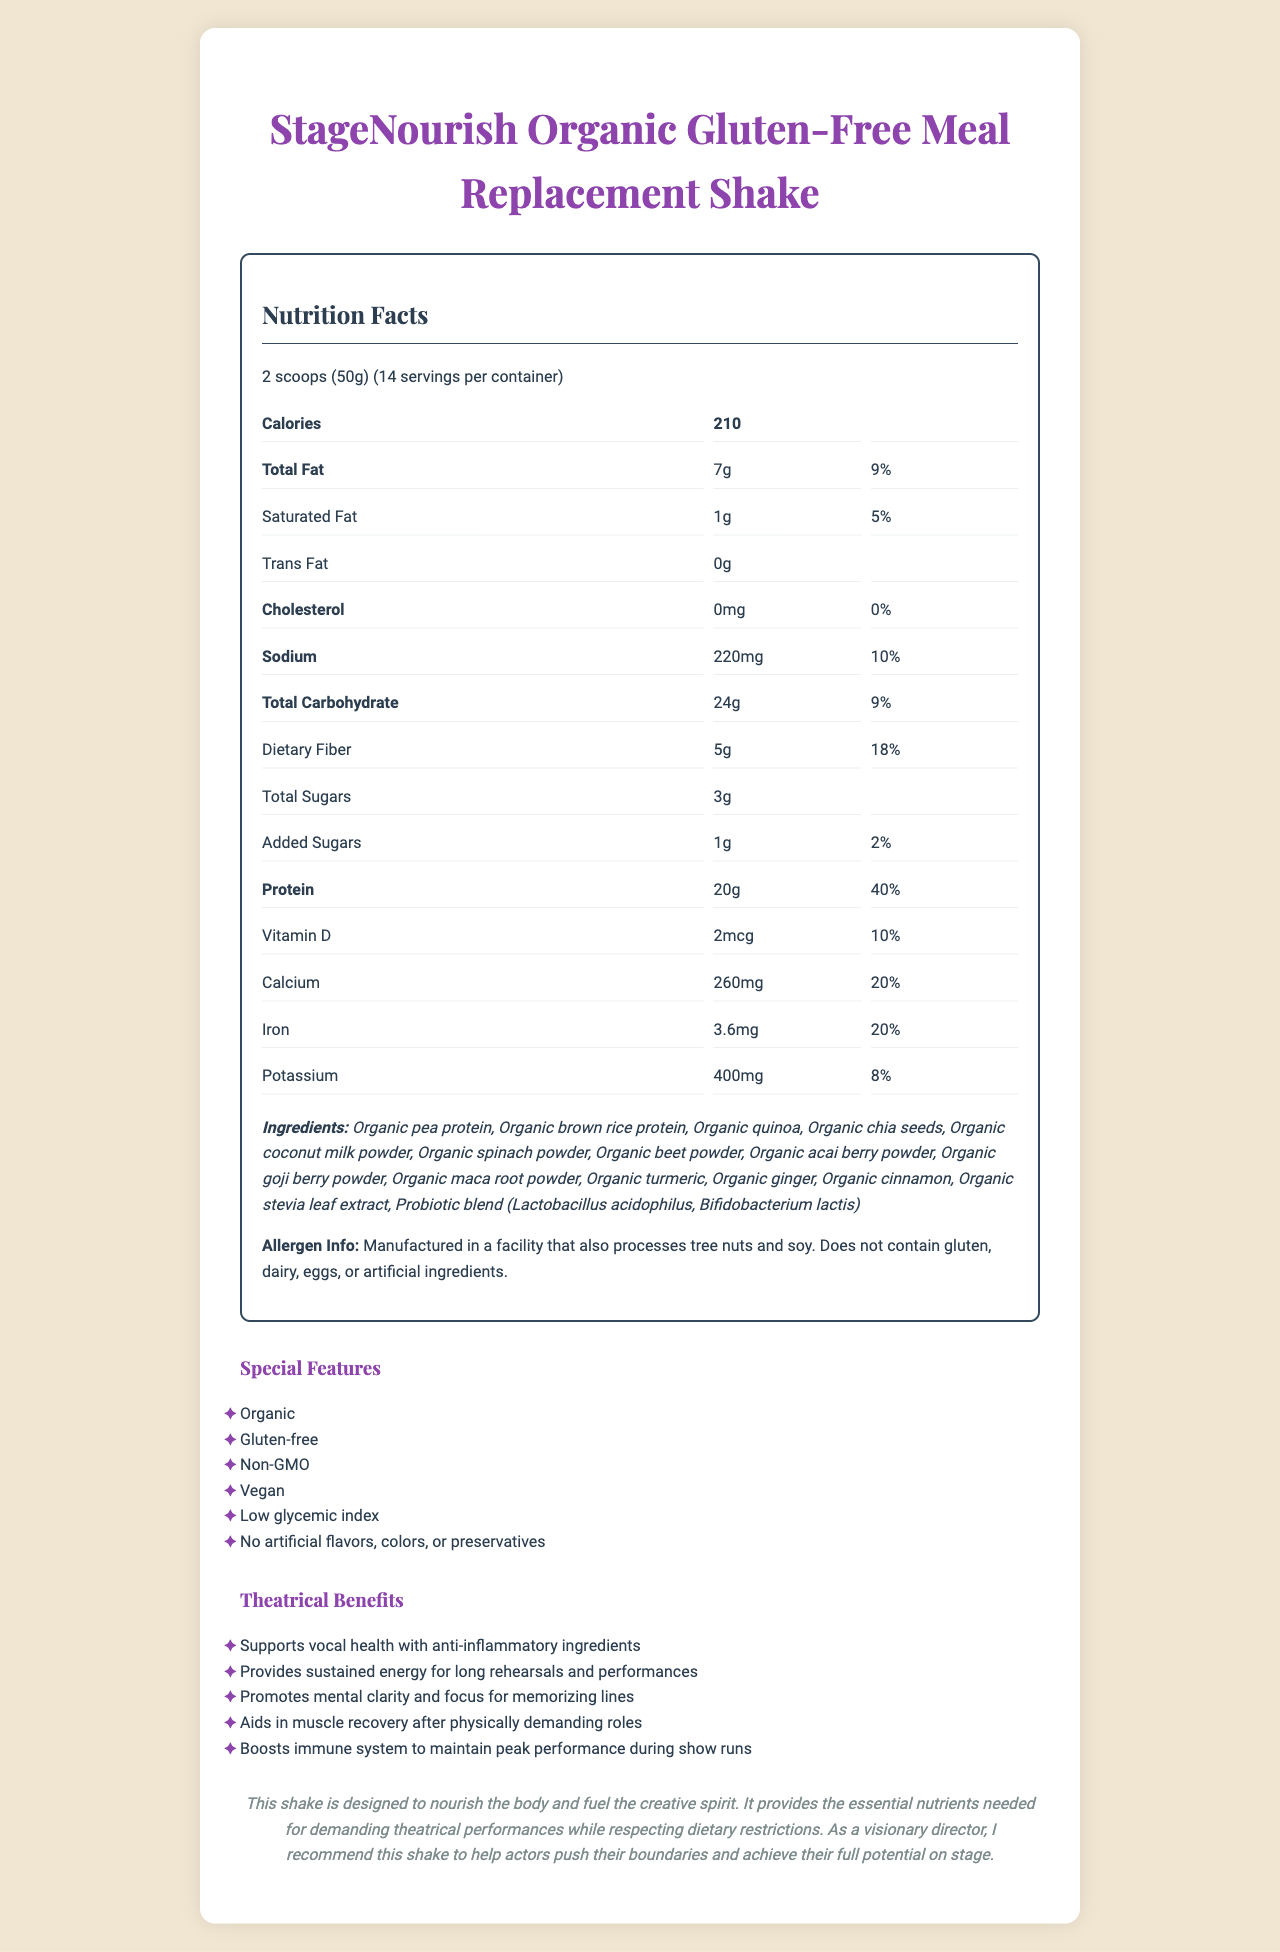what is the serving size for the StageNourish meal replacement shake? The serving size is mentioned at the top of the nutrition label section.
Answer: 2 scoops (50g) how many calories are in a single serving? The number of calories per serving is listed in the nutrition facts under "Calories".
Answer: 210 what is the total fat content per serving? The total fat amount per serving is indicated in the nutrition facts section.
Answer: 7g how much dietary fiber does one serving contain? The dietary fiber content per serving is found under the carbohydrate section in the nutrition facts.
Answer: 5g which ingredients are organic in this shake? The ingredients list specifies that all these components are organic.
Answer: Organic pea protein, Organic brown rice protein, Organic quinoa, Organic chia seeds, Organic coconut milk powder, Organic spinach powder, Organic beet powder, Organic acai berry powder, Organic goji berry powder, Organic maca root powder, Organic turmeric, Organic ginger, Organic cinnamon, Organic stevia leaf extract how much protein does the shake provide per serving? The protein content per serving is displayed in the nutrition facts segment.
Answer: 20g how many servings are there per container? This information is displayed in the nutrition facts section under the servings per container.
Answer: 14 what percentage of the daily value for iron is provided in one serving? The daily value percentage for iron can be found in the nutrition facts section.
Answer: 20% which of the following allergens are processed in the same facility as the StageNourish shake? A. Dairy, Nuts, Soy B. Gluten, Tree nuts, Dairy C. Tree nuts, Nuts, Dairy D. Tree nuts, Soy, Dairy The allergen info states "Manufactured in a facility that also processes tree nuts and soy."
Answer: D how much added sugars does each serving contain? A. 1g B. 2g C. 3g D. 5g The amount of added sugars is stated as 1g in the nutrition facts section.
Answer: A is the StageNourish shake gluten-free? The product name clearly mentions "Gluten-Free", and it's reiterated in the special features.
Answer: Yes does the shake contain any artificial ingredients? The special features state that there are no artificial flavors, colors, or preservatives.
Answer: No describe the main advantages that StageNourish provides for actors. These benefits are listed under the theatrical benefits section and directed specifically at supporting actors' needs.
Answer: Supports vocal health, provides sustained energy, promotes mental clarity and focus, aids in muscle recovery, boosts immune system what other dietary restrictions does the StageNourish shake respect besides being gluten-free? These are listed under the special features section.
Answer: Vegan, Non-GMO, Low glycemic index, No artificial flavors, colors, or preservatives what is the special note from the director about the shake? This information is contained in the director notes section at the bottom of the document.
Answer: The shake is designed to nourish the body and fuel the creative spirit, providing essential nutrients for demanding theatrical performances while respecting dietary restrictions. It helps actors push their boundaries and achieve their full potential on stage. how much Vitamin B12 is in one serving? The Vitamin B12 content is listed in the nutrition facts section.
Answer: 0.6mcg what is the purpose of the probiotic blend in the ingredients? The document does not explain the specific purpose of the probiotic blend in the shake.
Answer: Not enough information 